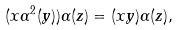Convert formula to latex. <formula><loc_0><loc_0><loc_500><loc_500>( x \alpha ^ { 2 } ( y ) ) \alpha ( z ) = ( x y ) \alpha ( z ) ,</formula> 